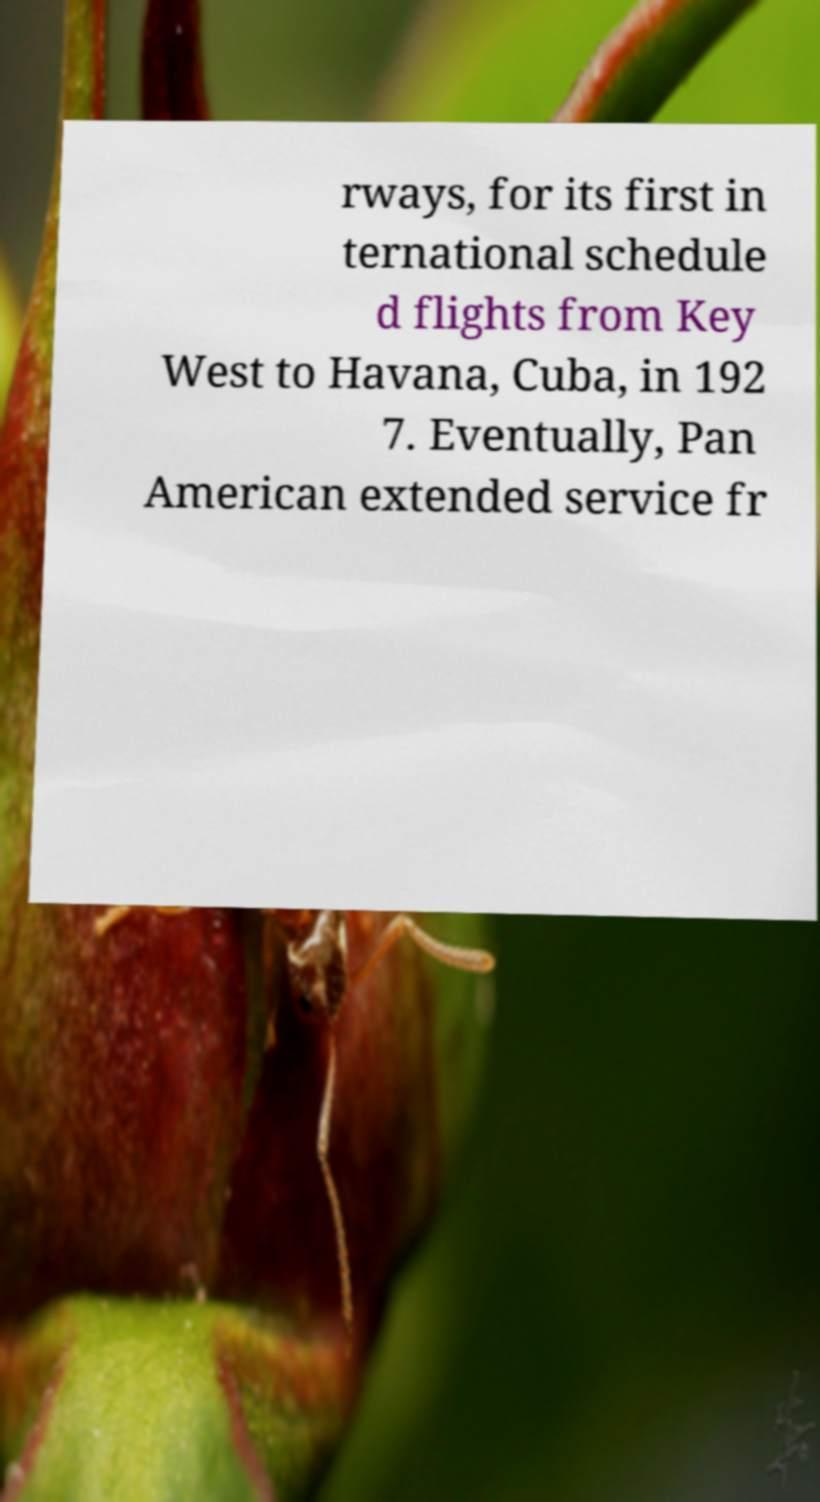There's text embedded in this image that I need extracted. Can you transcribe it verbatim? rways, for its first in ternational schedule d flights from Key West to Havana, Cuba, in 192 7. Eventually, Pan American extended service fr 